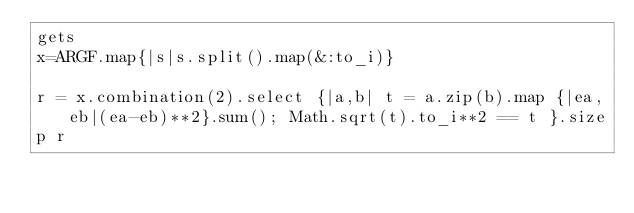Convert code to text. <code><loc_0><loc_0><loc_500><loc_500><_Ruby_>gets
x=ARGF.map{|s|s.split().map(&:to_i)}

r = x.combination(2).select {|a,b| t = a.zip(b).map {|ea,eb|(ea-eb)**2}.sum(); Math.sqrt(t).to_i**2 == t }.size
p r</code> 